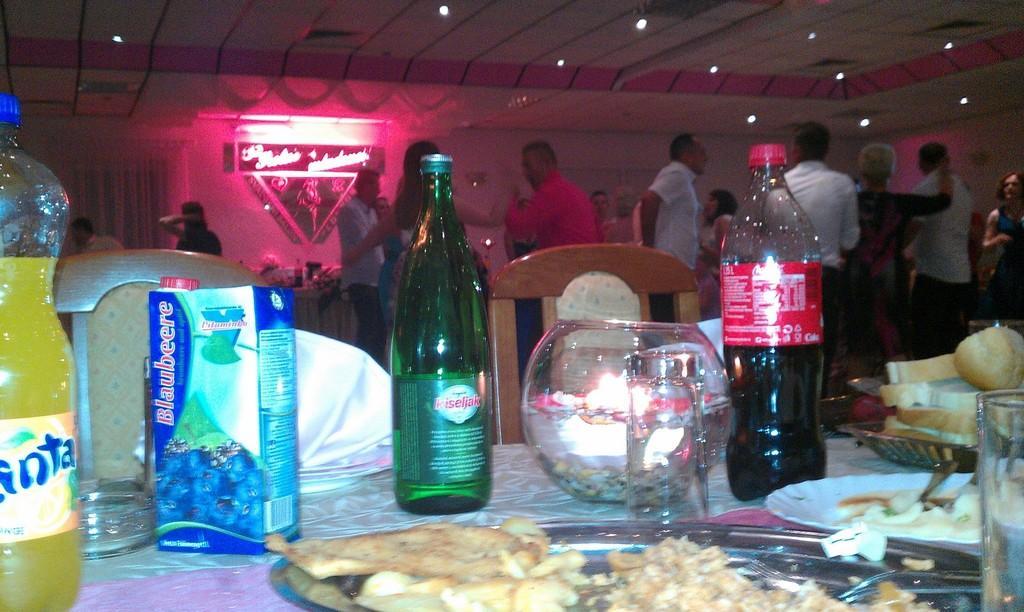Describe this image in one or two sentences. In this picture there are some cool drink bottles, glasses, and food items on the table, there are chairs around the table and the people are dancing at the right side of the image, there are spotlights above the stage, it seems to be party. 